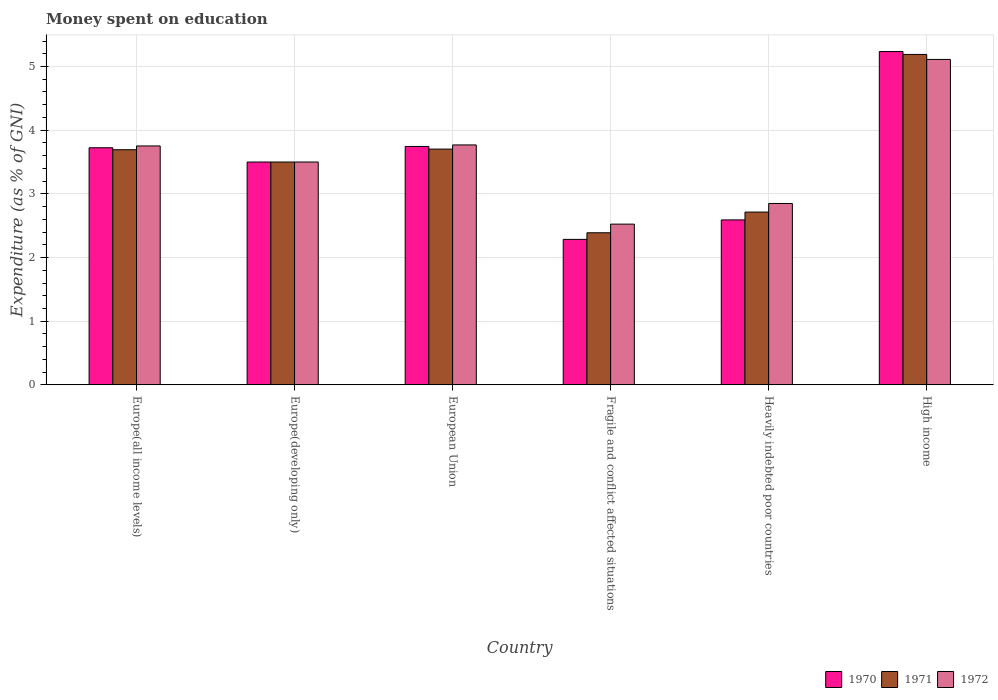How many different coloured bars are there?
Ensure brevity in your answer.  3. How many groups of bars are there?
Offer a very short reply. 6. Are the number of bars per tick equal to the number of legend labels?
Provide a succinct answer. Yes. Are the number of bars on each tick of the X-axis equal?
Keep it short and to the point. Yes. How many bars are there on the 2nd tick from the right?
Offer a terse response. 3. What is the label of the 1st group of bars from the left?
Offer a terse response. Europe(all income levels). Across all countries, what is the maximum amount of money spent on education in 1970?
Make the answer very short. 5.23. Across all countries, what is the minimum amount of money spent on education in 1972?
Give a very brief answer. 2.52. In which country was the amount of money spent on education in 1970 maximum?
Provide a succinct answer. High income. In which country was the amount of money spent on education in 1970 minimum?
Make the answer very short. Fragile and conflict affected situations. What is the total amount of money spent on education in 1971 in the graph?
Provide a short and direct response. 21.19. What is the difference between the amount of money spent on education in 1970 in Europe(all income levels) and that in Heavily indebted poor countries?
Offer a very short reply. 1.13. What is the difference between the amount of money spent on education in 1970 in European Union and the amount of money spent on education in 1971 in Fragile and conflict affected situations?
Give a very brief answer. 1.36. What is the average amount of money spent on education in 1971 per country?
Provide a succinct answer. 3.53. What is the difference between the amount of money spent on education of/in 1972 and amount of money spent on education of/in 1970 in European Union?
Provide a succinct answer. 0.02. In how many countries, is the amount of money spent on education in 1970 greater than 1.2 %?
Your answer should be very brief. 6. What is the ratio of the amount of money spent on education in 1970 in Europe(developing only) to that in High income?
Offer a terse response. 0.67. Is the amount of money spent on education in 1972 in Fragile and conflict affected situations less than that in Heavily indebted poor countries?
Make the answer very short. Yes. Is the difference between the amount of money spent on education in 1972 in European Union and High income greater than the difference between the amount of money spent on education in 1970 in European Union and High income?
Keep it short and to the point. Yes. What is the difference between the highest and the second highest amount of money spent on education in 1971?
Offer a very short reply. -0.01. What is the difference between the highest and the lowest amount of money spent on education in 1971?
Offer a terse response. 2.8. What does the 3rd bar from the left in High income represents?
Your answer should be compact. 1972. How many bars are there?
Keep it short and to the point. 18. Are all the bars in the graph horizontal?
Make the answer very short. No. How many countries are there in the graph?
Provide a short and direct response. 6. What is the difference between two consecutive major ticks on the Y-axis?
Your answer should be very brief. 1. Does the graph contain any zero values?
Offer a terse response. No. How are the legend labels stacked?
Ensure brevity in your answer.  Horizontal. What is the title of the graph?
Keep it short and to the point. Money spent on education. Does "1993" appear as one of the legend labels in the graph?
Your answer should be very brief. No. What is the label or title of the X-axis?
Ensure brevity in your answer.  Country. What is the label or title of the Y-axis?
Give a very brief answer. Expenditure (as % of GNI). What is the Expenditure (as % of GNI) in 1970 in Europe(all income levels)?
Your answer should be compact. 3.72. What is the Expenditure (as % of GNI) in 1971 in Europe(all income levels)?
Offer a very short reply. 3.69. What is the Expenditure (as % of GNI) of 1972 in Europe(all income levels)?
Provide a succinct answer. 3.75. What is the Expenditure (as % of GNI) in 1970 in Europe(developing only)?
Your answer should be compact. 3.5. What is the Expenditure (as % of GNI) in 1971 in Europe(developing only)?
Your response must be concise. 3.5. What is the Expenditure (as % of GNI) in 1972 in Europe(developing only)?
Make the answer very short. 3.5. What is the Expenditure (as % of GNI) in 1970 in European Union?
Your answer should be very brief. 3.74. What is the Expenditure (as % of GNI) in 1971 in European Union?
Your answer should be compact. 3.7. What is the Expenditure (as % of GNI) of 1972 in European Union?
Ensure brevity in your answer.  3.77. What is the Expenditure (as % of GNI) of 1970 in Fragile and conflict affected situations?
Keep it short and to the point. 2.29. What is the Expenditure (as % of GNI) in 1971 in Fragile and conflict affected situations?
Give a very brief answer. 2.39. What is the Expenditure (as % of GNI) in 1972 in Fragile and conflict affected situations?
Make the answer very short. 2.52. What is the Expenditure (as % of GNI) of 1970 in Heavily indebted poor countries?
Provide a succinct answer. 2.59. What is the Expenditure (as % of GNI) in 1971 in Heavily indebted poor countries?
Offer a terse response. 2.71. What is the Expenditure (as % of GNI) of 1972 in Heavily indebted poor countries?
Offer a terse response. 2.85. What is the Expenditure (as % of GNI) in 1970 in High income?
Keep it short and to the point. 5.23. What is the Expenditure (as % of GNI) in 1971 in High income?
Provide a short and direct response. 5.19. What is the Expenditure (as % of GNI) in 1972 in High income?
Your answer should be very brief. 5.11. Across all countries, what is the maximum Expenditure (as % of GNI) of 1970?
Offer a very short reply. 5.23. Across all countries, what is the maximum Expenditure (as % of GNI) in 1971?
Ensure brevity in your answer.  5.19. Across all countries, what is the maximum Expenditure (as % of GNI) in 1972?
Provide a short and direct response. 5.11. Across all countries, what is the minimum Expenditure (as % of GNI) in 1970?
Give a very brief answer. 2.29. Across all countries, what is the minimum Expenditure (as % of GNI) in 1971?
Your response must be concise. 2.39. Across all countries, what is the minimum Expenditure (as % of GNI) in 1972?
Provide a succinct answer. 2.52. What is the total Expenditure (as % of GNI) of 1970 in the graph?
Your answer should be very brief. 21.08. What is the total Expenditure (as % of GNI) in 1971 in the graph?
Your response must be concise. 21.19. What is the total Expenditure (as % of GNI) in 1972 in the graph?
Provide a succinct answer. 21.51. What is the difference between the Expenditure (as % of GNI) in 1970 in Europe(all income levels) and that in Europe(developing only)?
Make the answer very short. 0.22. What is the difference between the Expenditure (as % of GNI) in 1971 in Europe(all income levels) and that in Europe(developing only)?
Your answer should be very brief. 0.19. What is the difference between the Expenditure (as % of GNI) of 1972 in Europe(all income levels) and that in Europe(developing only)?
Keep it short and to the point. 0.25. What is the difference between the Expenditure (as % of GNI) in 1970 in Europe(all income levels) and that in European Union?
Provide a short and direct response. -0.02. What is the difference between the Expenditure (as % of GNI) in 1971 in Europe(all income levels) and that in European Union?
Provide a succinct answer. -0.01. What is the difference between the Expenditure (as % of GNI) in 1972 in Europe(all income levels) and that in European Union?
Offer a very short reply. -0.02. What is the difference between the Expenditure (as % of GNI) of 1970 in Europe(all income levels) and that in Fragile and conflict affected situations?
Keep it short and to the point. 1.44. What is the difference between the Expenditure (as % of GNI) in 1971 in Europe(all income levels) and that in Fragile and conflict affected situations?
Provide a short and direct response. 1.3. What is the difference between the Expenditure (as % of GNI) of 1972 in Europe(all income levels) and that in Fragile and conflict affected situations?
Provide a succinct answer. 1.23. What is the difference between the Expenditure (as % of GNI) of 1970 in Europe(all income levels) and that in Heavily indebted poor countries?
Your answer should be compact. 1.13. What is the difference between the Expenditure (as % of GNI) of 1971 in Europe(all income levels) and that in Heavily indebted poor countries?
Keep it short and to the point. 0.98. What is the difference between the Expenditure (as % of GNI) in 1972 in Europe(all income levels) and that in Heavily indebted poor countries?
Ensure brevity in your answer.  0.9. What is the difference between the Expenditure (as % of GNI) of 1970 in Europe(all income levels) and that in High income?
Offer a terse response. -1.51. What is the difference between the Expenditure (as % of GNI) of 1971 in Europe(all income levels) and that in High income?
Your answer should be compact. -1.5. What is the difference between the Expenditure (as % of GNI) of 1972 in Europe(all income levels) and that in High income?
Provide a short and direct response. -1.36. What is the difference between the Expenditure (as % of GNI) in 1970 in Europe(developing only) and that in European Union?
Offer a very short reply. -0.24. What is the difference between the Expenditure (as % of GNI) of 1971 in Europe(developing only) and that in European Union?
Provide a short and direct response. -0.2. What is the difference between the Expenditure (as % of GNI) of 1972 in Europe(developing only) and that in European Union?
Your answer should be very brief. -0.27. What is the difference between the Expenditure (as % of GNI) in 1970 in Europe(developing only) and that in Fragile and conflict affected situations?
Offer a very short reply. 1.21. What is the difference between the Expenditure (as % of GNI) in 1971 in Europe(developing only) and that in Fragile and conflict affected situations?
Your answer should be compact. 1.11. What is the difference between the Expenditure (as % of GNI) in 1972 in Europe(developing only) and that in Fragile and conflict affected situations?
Ensure brevity in your answer.  0.98. What is the difference between the Expenditure (as % of GNI) of 1970 in Europe(developing only) and that in Heavily indebted poor countries?
Your response must be concise. 0.91. What is the difference between the Expenditure (as % of GNI) of 1971 in Europe(developing only) and that in Heavily indebted poor countries?
Make the answer very short. 0.79. What is the difference between the Expenditure (as % of GNI) in 1972 in Europe(developing only) and that in Heavily indebted poor countries?
Offer a very short reply. 0.65. What is the difference between the Expenditure (as % of GNI) of 1970 in Europe(developing only) and that in High income?
Ensure brevity in your answer.  -1.73. What is the difference between the Expenditure (as % of GNI) of 1971 in Europe(developing only) and that in High income?
Offer a terse response. -1.69. What is the difference between the Expenditure (as % of GNI) in 1972 in Europe(developing only) and that in High income?
Give a very brief answer. -1.61. What is the difference between the Expenditure (as % of GNI) in 1970 in European Union and that in Fragile and conflict affected situations?
Your response must be concise. 1.46. What is the difference between the Expenditure (as % of GNI) in 1971 in European Union and that in Fragile and conflict affected situations?
Your answer should be very brief. 1.31. What is the difference between the Expenditure (as % of GNI) of 1972 in European Union and that in Fragile and conflict affected situations?
Make the answer very short. 1.24. What is the difference between the Expenditure (as % of GNI) in 1970 in European Union and that in Heavily indebted poor countries?
Ensure brevity in your answer.  1.15. What is the difference between the Expenditure (as % of GNI) of 1971 in European Union and that in Heavily indebted poor countries?
Provide a short and direct response. 0.99. What is the difference between the Expenditure (as % of GNI) in 1972 in European Union and that in Heavily indebted poor countries?
Keep it short and to the point. 0.92. What is the difference between the Expenditure (as % of GNI) in 1970 in European Union and that in High income?
Your answer should be very brief. -1.49. What is the difference between the Expenditure (as % of GNI) in 1971 in European Union and that in High income?
Offer a terse response. -1.49. What is the difference between the Expenditure (as % of GNI) in 1972 in European Union and that in High income?
Make the answer very short. -1.34. What is the difference between the Expenditure (as % of GNI) in 1970 in Fragile and conflict affected situations and that in Heavily indebted poor countries?
Your response must be concise. -0.31. What is the difference between the Expenditure (as % of GNI) of 1971 in Fragile and conflict affected situations and that in Heavily indebted poor countries?
Offer a very short reply. -0.33. What is the difference between the Expenditure (as % of GNI) in 1972 in Fragile and conflict affected situations and that in Heavily indebted poor countries?
Your response must be concise. -0.32. What is the difference between the Expenditure (as % of GNI) of 1970 in Fragile and conflict affected situations and that in High income?
Ensure brevity in your answer.  -2.95. What is the difference between the Expenditure (as % of GNI) of 1971 in Fragile and conflict affected situations and that in High income?
Provide a succinct answer. -2.8. What is the difference between the Expenditure (as % of GNI) in 1972 in Fragile and conflict affected situations and that in High income?
Offer a very short reply. -2.59. What is the difference between the Expenditure (as % of GNI) of 1970 in Heavily indebted poor countries and that in High income?
Offer a terse response. -2.64. What is the difference between the Expenditure (as % of GNI) of 1971 in Heavily indebted poor countries and that in High income?
Make the answer very short. -2.48. What is the difference between the Expenditure (as % of GNI) in 1972 in Heavily indebted poor countries and that in High income?
Your answer should be compact. -2.26. What is the difference between the Expenditure (as % of GNI) of 1970 in Europe(all income levels) and the Expenditure (as % of GNI) of 1971 in Europe(developing only)?
Offer a terse response. 0.22. What is the difference between the Expenditure (as % of GNI) of 1970 in Europe(all income levels) and the Expenditure (as % of GNI) of 1972 in Europe(developing only)?
Offer a very short reply. 0.22. What is the difference between the Expenditure (as % of GNI) of 1971 in Europe(all income levels) and the Expenditure (as % of GNI) of 1972 in Europe(developing only)?
Provide a succinct answer. 0.19. What is the difference between the Expenditure (as % of GNI) of 1970 in Europe(all income levels) and the Expenditure (as % of GNI) of 1971 in European Union?
Make the answer very short. 0.02. What is the difference between the Expenditure (as % of GNI) of 1970 in Europe(all income levels) and the Expenditure (as % of GNI) of 1972 in European Union?
Offer a terse response. -0.04. What is the difference between the Expenditure (as % of GNI) in 1971 in Europe(all income levels) and the Expenditure (as % of GNI) in 1972 in European Union?
Provide a succinct answer. -0.08. What is the difference between the Expenditure (as % of GNI) of 1970 in Europe(all income levels) and the Expenditure (as % of GNI) of 1971 in Fragile and conflict affected situations?
Your response must be concise. 1.34. What is the difference between the Expenditure (as % of GNI) in 1970 in Europe(all income levels) and the Expenditure (as % of GNI) in 1972 in Fragile and conflict affected situations?
Your answer should be compact. 1.2. What is the difference between the Expenditure (as % of GNI) of 1971 in Europe(all income levels) and the Expenditure (as % of GNI) of 1972 in Fragile and conflict affected situations?
Make the answer very short. 1.17. What is the difference between the Expenditure (as % of GNI) in 1970 in Europe(all income levels) and the Expenditure (as % of GNI) in 1971 in Heavily indebted poor countries?
Keep it short and to the point. 1.01. What is the difference between the Expenditure (as % of GNI) of 1970 in Europe(all income levels) and the Expenditure (as % of GNI) of 1972 in Heavily indebted poor countries?
Provide a short and direct response. 0.88. What is the difference between the Expenditure (as % of GNI) in 1971 in Europe(all income levels) and the Expenditure (as % of GNI) in 1972 in Heavily indebted poor countries?
Offer a very short reply. 0.84. What is the difference between the Expenditure (as % of GNI) in 1970 in Europe(all income levels) and the Expenditure (as % of GNI) in 1971 in High income?
Offer a very short reply. -1.47. What is the difference between the Expenditure (as % of GNI) in 1970 in Europe(all income levels) and the Expenditure (as % of GNI) in 1972 in High income?
Ensure brevity in your answer.  -1.39. What is the difference between the Expenditure (as % of GNI) of 1971 in Europe(all income levels) and the Expenditure (as % of GNI) of 1972 in High income?
Offer a terse response. -1.42. What is the difference between the Expenditure (as % of GNI) of 1970 in Europe(developing only) and the Expenditure (as % of GNI) of 1971 in European Union?
Keep it short and to the point. -0.2. What is the difference between the Expenditure (as % of GNI) in 1970 in Europe(developing only) and the Expenditure (as % of GNI) in 1972 in European Union?
Your answer should be compact. -0.27. What is the difference between the Expenditure (as % of GNI) in 1971 in Europe(developing only) and the Expenditure (as % of GNI) in 1972 in European Union?
Make the answer very short. -0.27. What is the difference between the Expenditure (as % of GNI) in 1970 in Europe(developing only) and the Expenditure (as % of GNI) in 1971 in Fragile and conflict affected situations?
Offer a very short reply. 1.11. What is the difference between the Expenditure (as % of GNI) in 1970 in Europe(developing only) and the Expenditure (as % of GNI) in 1972 in Fragile and conflict affected situations?
Offer a terse response. 0.98. What is the difference between the Expenditure (as % of GNI) of 1971 in Europe(developing only) and the Expenditure (as % of GNI) of 1972 in Fragile and conflict affected situations?
Provide a short and direct response. 0.98. What is the difference between the Expenditure (as % of GNI) of 1970 in Europe(developing only) and the Expenditure (as % of GNI) of 1971 in Heavily indebted poor countries?
Offer a terse response. 0.79. What is the difference between the Expenditure (as % of GNI) in 1970 in Europe(developing only) and the Expenditure (as % of GNI) in 1972 in Heavily indebted poor countries?
Give a very brief answer. 0.65. What is the difference between the Expenditure (as % of GNI) in 1971 in Europe(developing only) and the Expenditure (as % of GNI) in 1972 in Heavily indebted poor countries?
Your answer should be compact. 0.65. What is the difference between the Expenditure (as % of GNI) in 1970 in Europe(developing only) and the Expenditure (as % of GNI) in 1971 in High income?
Offer a very short reply. -1.69. What is the difference between the Expenditure (as % of GNI) of 1970 in Europe(developing only) and the Expenditure (as % of GNI) of 1972 in High income?
Make the answer very short. -1.61. What is the difference between the Expenditure (as % of GNI) of 1971 in Europe(developing only) and the Expenditure (as % of GNI) of 1972 in High income?
Your answer should be very brief. -1.61. What is the difference between the Expenditure (as % of GNI) of 1970 in European Union and the Expenditure (as % of GNI) of 1971 in Fragile and conflict affected situations?
Your response must be concise. 1.36. What is the difference between the Expenditure (as % of GNI) in 1970 in European Union and the Expenditure (as % of GNI) in 1972 in Fragile and conflict affected situations?
Provide a short and direct response. 1.22. What is the difference between the Expenditure (as % of GNI) of 1971 in European Union and the Expenditure (as % of GNI) of 1972 in Fragile and conflict affected situations?
Your response must be concise. 1.18. What is the difference between the Expenditure (as % of GNI) of 1970 in European Union and the Expenditure (as % of GNI) of 1971 in Heavily indebted poor countries?
Provide a short and direct response. 1.03. What is the difference between the Expenditure (as % of GNI) in 1970 in European Union and the Expenditure (as % of GNI) in 1972 in Heavily indebted poor countries?
Make the answer very short. 0.9. What is the difference between the Expenditure (as % of GNI) of 1971 in European Union and the Expenditure (as % of GNI) of 1972 in Heavily indebted poor countries?
Your answer should be compact. 0.85. What is the difference between the Expenditure (as % of GNI) in 1970 in European Union and the Expenditure (as % of GNI) in 1971 in High income?
Your answer should be very brief. -1.44. What is the difference between the Expenditure (as % of GNI) of 1970 in European Union and the Expenditure (as % of GNI) of 1972 in High income?
Offer a terse response. -1.37. What is the difference between the Expenditure (as % of GNI) in 1971 in European Union and the Expenditure (as % of GNI) in 1972 in High income?
Provide a short and direct response. -1.41. What is the difference between the Expenditure (as % of GNI) in 1970 in Fragile and conflict affected situations and the Expenditure (as % of GNI) in 1971 in Heavily indebted poor countries?
Give a very brief answer. -0.43. What is the difference between the Expenditure (as % of GNI) in 1970 in Fragile and conflict affected situations and the Expenditure (as % of GNI) in 1972 in Heavily indebted poor countries?
Make the answer very short. -0.56. What is the difference between the Expenditure (as % of GNI) of 1971 in Fragile and conflict affected situations and the Expenditure (as % of GNI) of 1972 in Heavily indebted poor countries?
Your answer should be very brief. -0.46. What is the difference between the Expenditure (as % of GNI) of 1970 in Fragile and conflict affected situations and the Expenditure (as % of GNI) of 1971 in High income?
Make the answer very short. -2.9. What is the difference between the Expenditure (as % of GNI) in 1970 in Fragile and conflict affected situations and the Expenditure (as % of GNI) in 1972 in High income?
Ensure brevity in your answer.  -2.83. What is the difference between the Expenditure (as % of GNI) of 1971 in Fragile and conflict affected situations and the Expenditure (as % of GNI) of 1972 in High income?
Provide a short and direct response. -2.72. What is the difference between the Expenditure (as % of GNI) of 1970 in Heavily indebted poor countries and the Expenditure (as % of GNI) of 1971 in High income?
Ensure brevity in your answer.  -2.6. What is the difference between the Expenditure (as % of GNI) of 1970 in Heavily indebted poor countries and the Expenditure (as % of GNI) of 1972 in High income?
Your answer should be very brief. -2.52. What is the difference between the Expenditure (as % of GNI) of 1971 in Heavily indebted poor countries and the Expenditure (as % of GNI) of 1972 in High income?
Give a very brief answer. -2.4. What is the average Expenditure (as % of GNI) of 1970 per country?
Make the answer very short. 3.51. What is the average Expenditure (as % of GNI) in 1971 per country?
Ensure brevity in your answer.  3.53. What is the average Expenditure (as % of GNI) in 1972 per country?
Make the answer very short. 3.58. What is the difference between the Expenditure (as % of GNI) of 1970 and Expenditure (as % of GNI) of 1971 in Europe(all income levels)?
Make the answer very short. 0.03. What is the difference between the Expenditure (as % of GNI) of 1970 and Expenditure (as % of GNI) of 1972 in Europe(all income levels)?
Offer a terse response. -0.03. What is the difference between the Expenditure (as % of GNI) in 1971 and Expenditure (as % of GNI) in 1972 in Europe(all income levels)?
Your response must be concise. -0.06. What is the difference between the Expenditure (as % of GNI) of 1970 and Expenditure (as % of GNI) of 1971 in European Union?
Offer a terse response. 0.04. What is the difference between the Expenditure (as % of GNI) of 1970 and Expenditure (as % of GNI) of 1972 in European Union?
Provide a short and direct response. -0.02. What is the difference between the Expenditure (as % of GNI) in 1971 and Expenditure (as % of GNI) in 1972 in European Union?
Make the answer very short. -0.07. What is the difference between the Expenditure (as % of GNI) of 1970 and Expenditure (as % of GNI) of 1971 in Fragile and conflict affected situations?
Provide a succinct answer. -0.1. What is the difference between the Expenditure (as % of GNI) of 1970 and Expenditure (as % of GNI) of 1972 in Fragile and conflict affected situations?
Ensure brevity in your answer.  -0.24. What is the difference between the Expenditure (as % of GNI) in 1971 and Expenditure (as % of GNI) in 1972 in Fragile and conflict affected situations?
Keep it short and to the point. -0.14. What is the difference between the Expenditure (as % of GNI) of 1970 and Expenditure (as % of GNI) of 1971 in Heavily indebted poor countries?
Ensure brevity in your answer.  -0.12. What is the difference between the Expenditure (as % of GNI) of 1970 and Expenditure (as % of GNI) of 1972 in Heavily indebted poor countries?
Keep it short and to the point. -0.26. What is the difference between the Expenditure (as % of GNI) in 1971 and Expenditure (as % of GNI) in 1972 in Heavily indebted poor countries?
Keep it short and to the point. -0.13. What is the difference between the Expenditure (as % of GNI) of 1970 and Expenditure (as % of GNI) of 1971 in High income?
Offer a terse response. 0.05. What is the difference between the Expenditure (as % of GNI) of 1970 and Expenditure (as % of GNI) of 1972 in High income?
Your response must be concise. 0.12. What is the difference between the Expenditure (as % of GNI) of 1971 and Expenditure (as % of GNI) of 1972 in High income?
Your answer should be compact. 0.08. What is the ratio of the Expenditure (as % of GNI) in 1970 in Europe(all income levels) to that in Europe(developing only)?
Provide a short and direct response. 1.06. What is the ratio of the Expenditure (as % of GNI) of 1971 in Europe(all income levels) to that in Europe(developing only)?
Provide a succinct answer. 1.06. What is the ratio of the Expenditure (as % of GNI) in 1972 in Europe(all income levels) to that in Europe(developing only)?
Make the answer very short. 1.07. What is the ratio of the Expenditure (as % of GNI) in 1970 in Europe(all income levels) to that in European Union?
Your answer should be very brief. 0.99. What is the ratio of the Expenditure (as % of GNI) of 1971 in Europe(all income levels) to that in European Union?
Your answer should be very brief. 1. What is the ratio of the Expenditure (as % of GNI) of 1972 in Europe(all income levels) to that in European Union?
Ensure brevity in your answer.  1. What is the ratio of the Expenditure (as % of GNI) in 1970 in Europe(all income levels) to that in Fragile and conflict affected situations?
Provide a succinct answer. 1.63. What is the ratio of the Expenditure (as % of GNI) of 1971 in Europe(all income levels) to that in Fragile and conflict affected situations?
Offer a terse response. 1.55. What is the ratio of the Expenditure (as % of GNI) of 1972 in Europe(all income levels) to that in Fragile and conflict affected situations?
Make the answer very short. 1.49. What is the ratio of the Expenditure (as % of GNI) in 1970 in Europe(all income levels) to that in Heavily indebted poor countries?
Provide a short and direct response. 1.44. What is the ratio of the Expenditure (as % of GNI) in 1971 in Europe(all income levels) to that in Heavily indebted poor countries?
Your answer should be compact. 1.36. What is the ratio of the Expenditure (as % of GNI) of 1972 in Europe(all income levels) to that in Heavily indebted poor countries?
Your answer should be compact. 1.32. What is the ratio of the Expenditure (as % of GNI) in 1970 in Europe(all income levels) to that in High income?
Keep it short and to the point. 0.71. What is the ratio of the Expenditure (as % of GNI) of 1971 in Europe(all income levels) to that in High income?
Your answer should be very brief. 0.71. What is the ratio of the Expenditure (as % of GNI) of 1972 in Europe(all income levels) to that in High income?
Give a very brief answer. 0.73. What is the ratio of the Expenditure (as % of GNI) of 1970 in Europe(developing only) to that in European Union?
Give a very brief answer. 0.93. What is the ratio of the Expenditure (as % of GNI) of 1971 in Europe(developing only) to that in European Union?
Give a very brief answer. 0.95. What is the ratio of the Expenditure (as % of GNI) of 1972 in Europe(developing only) to that in European Union?
Your answer should be compact. 0.93. What is the ratio of the Expenditure (as % of GNI) of 1970 in Europe(developing only) to that in Fragile and conflict affected situations?
Make the answer very short. 1.53. What is the ratio of the Expenditure (as % of GNI) of 1971 in Europe(developing only) to that in Fragile and conflict affected situations?
Offer a very short reply. 1.47. What is the ratio of the Expenditure (as % of GNI) in 1972 in Europe(developing only) to that in Fragile and conflict affected situations?
Provide a short and direct response. 1.39. What is the ratio of the Expenditure (as % of GNI) in 1970 in Europe(developing only) to that in Heavily indebted poor countries?
Offer a terse response. 1.35. What is the ratio of the Expenditure (as % of GNI) of 1971 in Europe(developing only) to that in Heavily indebted poor countries?
Provide a succinct answer. 1.29. What is the ratio of the Expenditure (as % of GNI) of 1972 in Europe(developing only) to that in Heavily indebted poor countries?
Keep it short and to the point. 1.23. What is the ratio of the Expenditure (as % of GNI) in 1970 in Europe(developing only) to that in High income?
Your answer should be compact. 0.67. What is the ratio of the Expenditure (as % of GNI) in 1971 in Europe(developing only) to that in High income?
Your answer should be compact. 0.67. What is the ratio of the Expenditure (as % of GNI) in 1972 in Europe(developing only) to that in High income?
Your response must be concise. 0.68. What is the ratio of the Expenditure (as % of GNI) in 1970 in European Union to that in Fragile and conflict affected situations?
Make the answer very short. 1.64. What is the ratio of the Expenditure (as % of GNI) in 1971 in European Union to that in Fragile and conflict affected situations?
Provide a short and direct response. 1.55. What is the ratio of the Expenditure (as % of GNI) of 1972 in European Union to that in Fragile and conflict affected situations?
Provide a succinct answer. 1.49. What is the ratio of the Expenditure (as % of GNI) of 1970 in European Union to that in Heavily indebted poor countries?
Your answer should be compact. 1.45. What is the ratio of the Expenditure (as % of GNI) in 1971 in European Union to that in Heavily indebted poor countries?
Offer a very short reply. 1.36. What is the ratio of the Expenditure (as % of GNI) in 1972 in European Union to that in Heavily indebted poor countries?
Offer a very short reply. 1.32. What is the ratio of the Expenditure (as % of GNI) in 1970 in European Union to that in High income?
Your response must be concise. 0.72. What is the ratio of the Expenditure (as % of GNI) in 1971 in European Union to that in High income?
Offer a very short reply. 0.71. What is the ratio of the Expenditure (as % of GNI) of 1972 in European Union to that in High income?
Your response must be concise. 0.74. What is the ratio of the Expenditure (as % of GNI) of 1970 in Fragile and conflict affected situations to that in Heavily indebted poor countries?
Make the answer very short. 0.88. What is the ratio of the Expenditure (as % of GNI) of 1971 in Fragile and conflict affected situations to that in Heavily indebted poor countries?
Provide a succinct answer. 0.88. What is the ratio of the Expenditure (as % of GNI) of 1972 in Fragile and conflict affected situations to that in Heavily indebted poor countries?
Offer a terse response. 0.89. What is the ratio of the Expenditure (as % of GNI) of 1970 in Fragile and conflict affected situations to that in High income?
Offer a very short reply. 0.44. What is the ratio of the Expenditure (as % of GNI) in 1971 in Fragile and conflict affected situations to that in High income?
Keep it short and to the point. 0.46. What is the ratio of the Expenditure (as % of GNI) in 1972 in Fragile and conflict affected situations to that in High income?
Your answer should be very brief. 0.49. What is the ratio of the Expenditure (as % of GNI) in 1970 in Heavily indebted poor countries to that in High income?
Keep it short and to the point. 0.49. What is the ratio of the Expenditure (as % of GNI) of 1971 in Heavily indebted poor countries to that in High income?
Offer a very short reply. 0.52. What is the ratio of the Expenditure (as % of GNI) of 1972 in Heavily indebted poor countries to that in High income?
Offer a very short reply. 0.56. What is the difference between the highest and the second highest Expenditure (as % of GNI) of 1970?
Offer a terse response. 1.49. What is the difference between the highest and the second highest Expenditure (as % of GNI) in 1971?
Give a very brief answer. 1.49. What is the difference between the highest and the second highest Expenditure (as % of GNI) of 1972?
Provide a short and direct response. 1.34. What is the difference between the highest and the lowest Expenditure (as % of GNI) in 1970?
Make the answer very short. 2.95. What is the difference between the highest and the lowest Expenditure (as % of GNI) in 1971?
Provide a succinct answer. 2.8. What is the difference between the highest and the lowest Expenditure (as % of GNI) in 1972?
Offer a terse response. 2.59. 